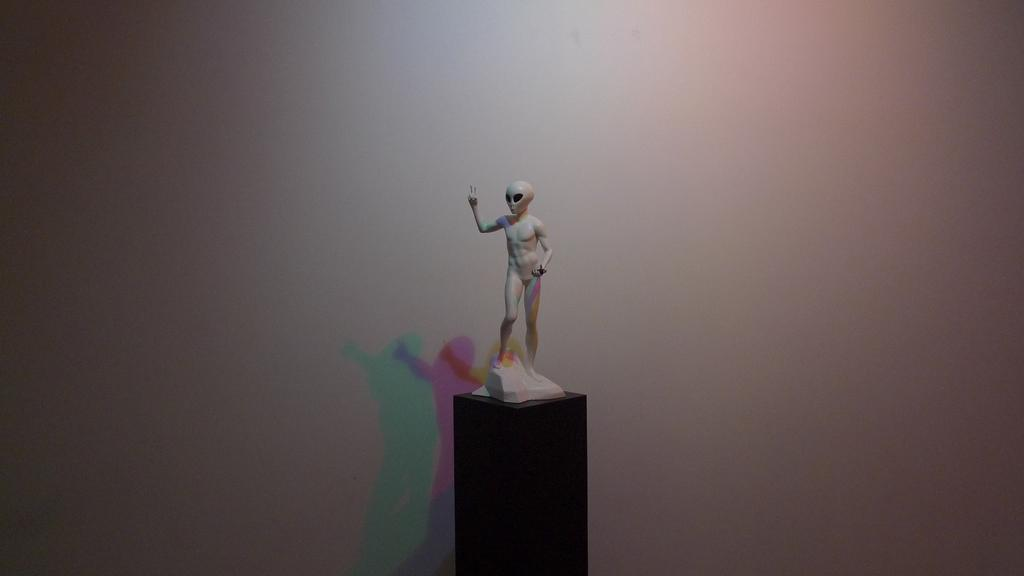What is the main subject in the image? There is a statue in the image. Where is the statue positioned? The statue is on a pillar. What is the color of the background in the image? The background of the image is white. Can you see any frogs interacting with the statue in the image? There are no frogs present in the image, and therefore no such interaction can be observed. What type of flesh can be seen on the statue in the image? There is no flesh visible on the statue in the image, as it is likely made of a non-organic material such as stone or metal. 